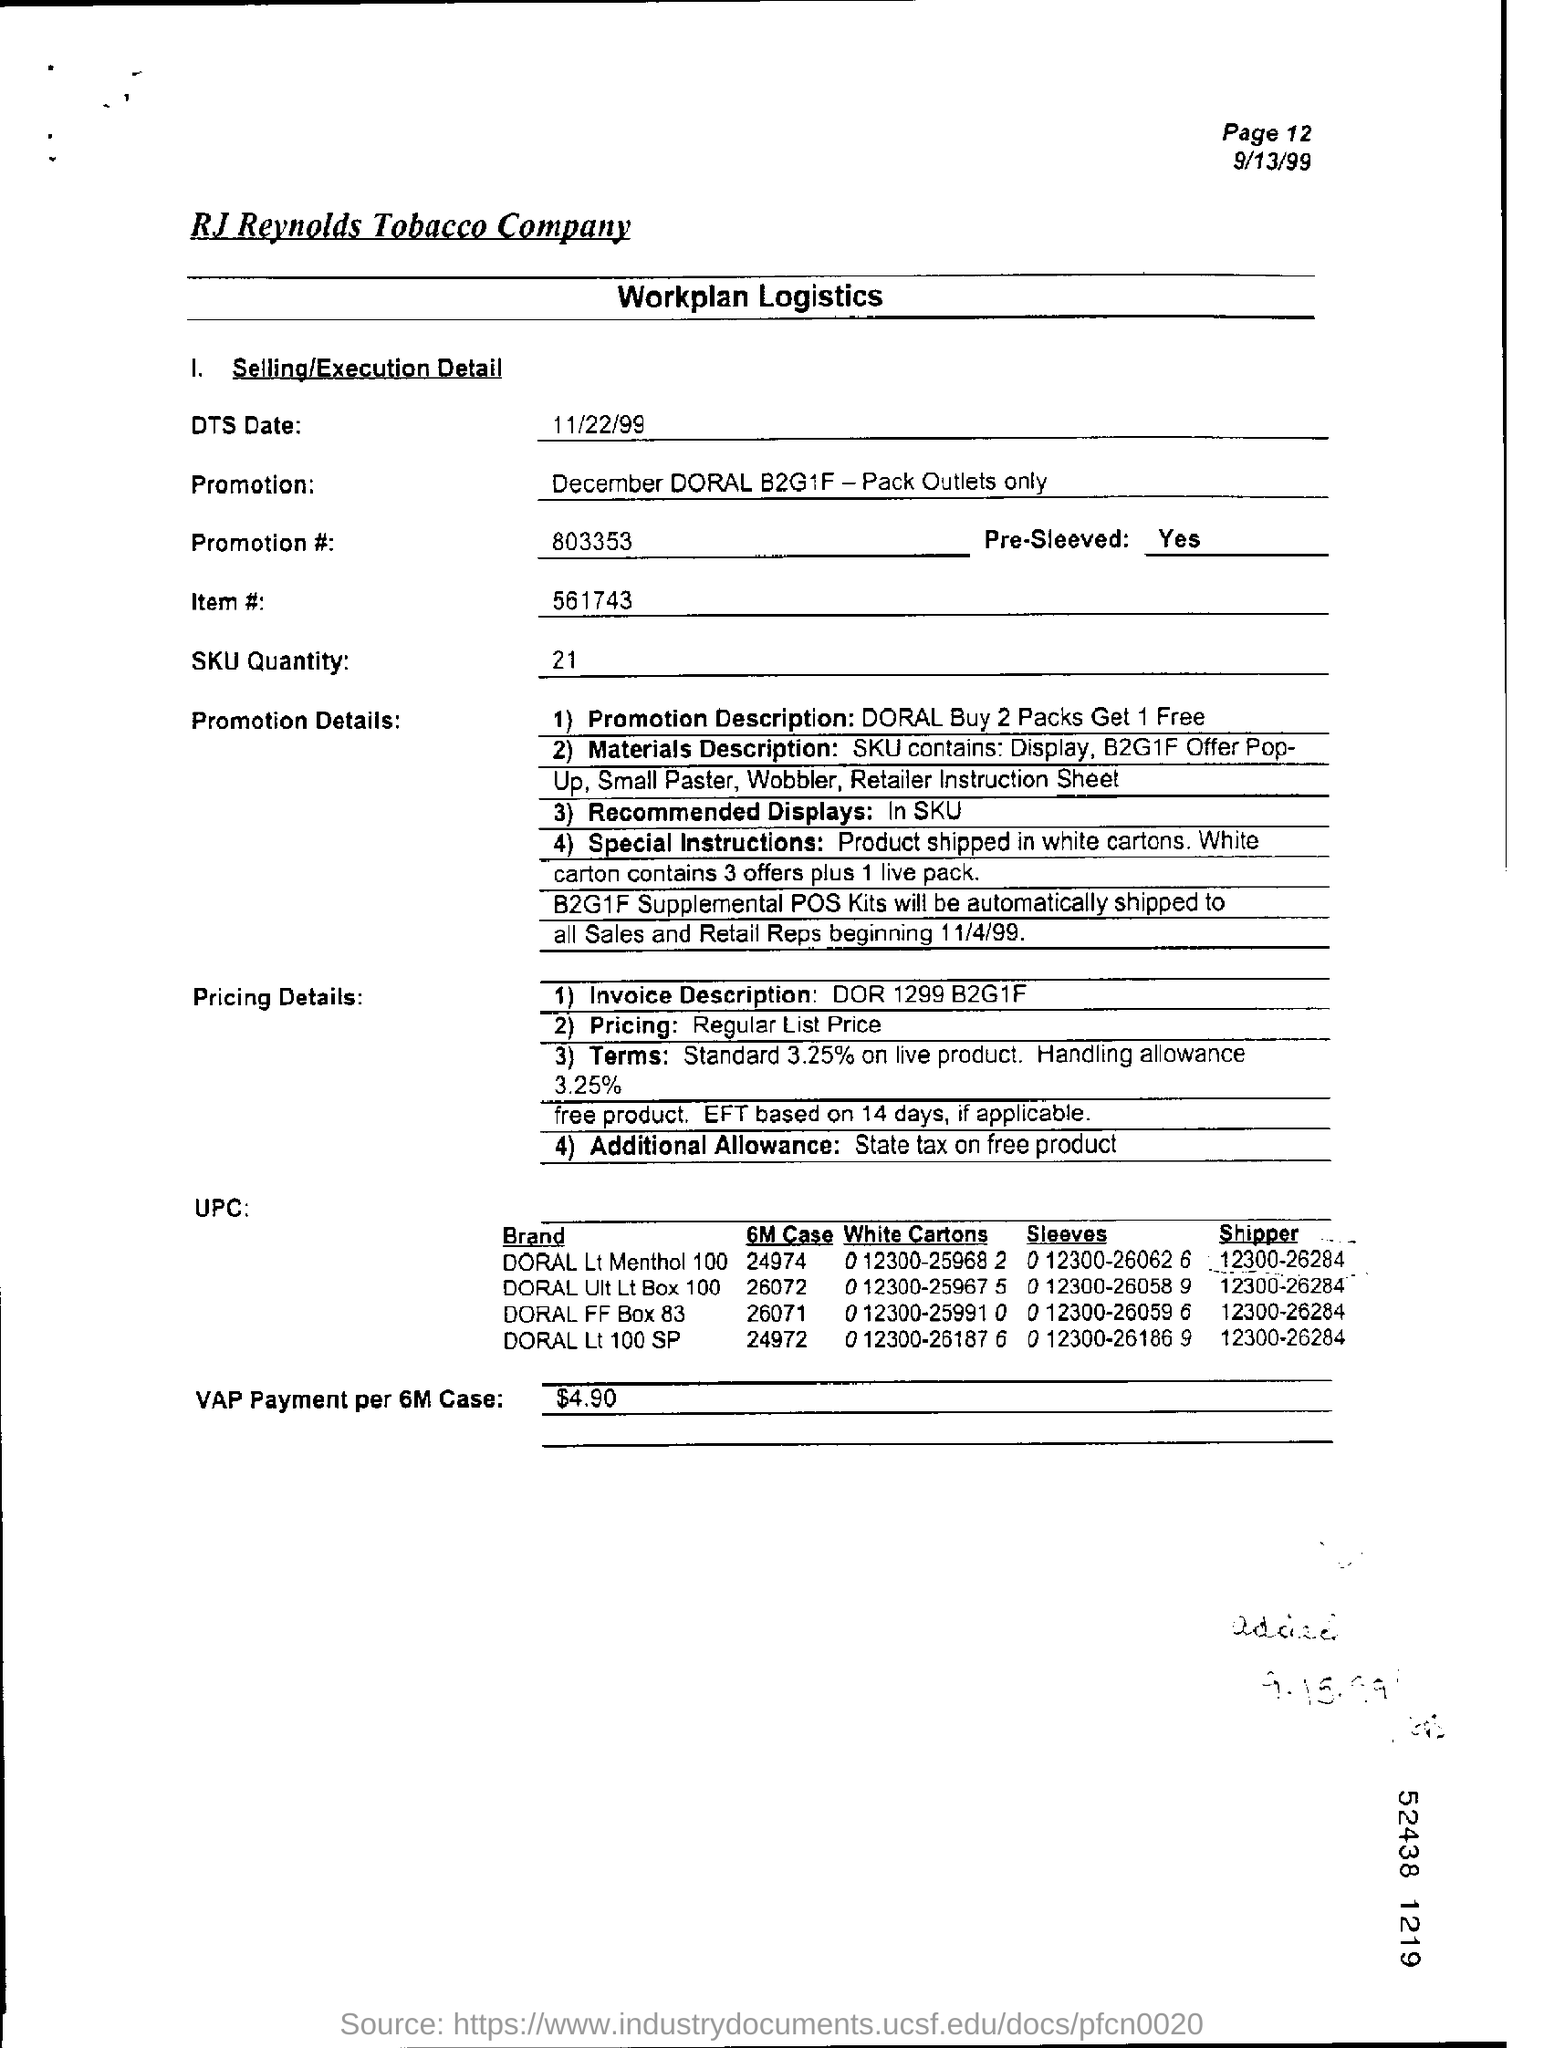Mention a couple of crucial points in this snapshot. The VAP payment per 6M case is $4.90. The promotion number on the page is 803353... I am on page 12 of a document and am inquiring about the page number of this page. The item number on the page is 561743... The SKU quantity on the page is 21. 